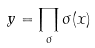Convert formula to latex. <formula><loc_0><loc_0><loc_500><loc_500>y = \prod _ { \sigma } \sigma ( x )</formula> 